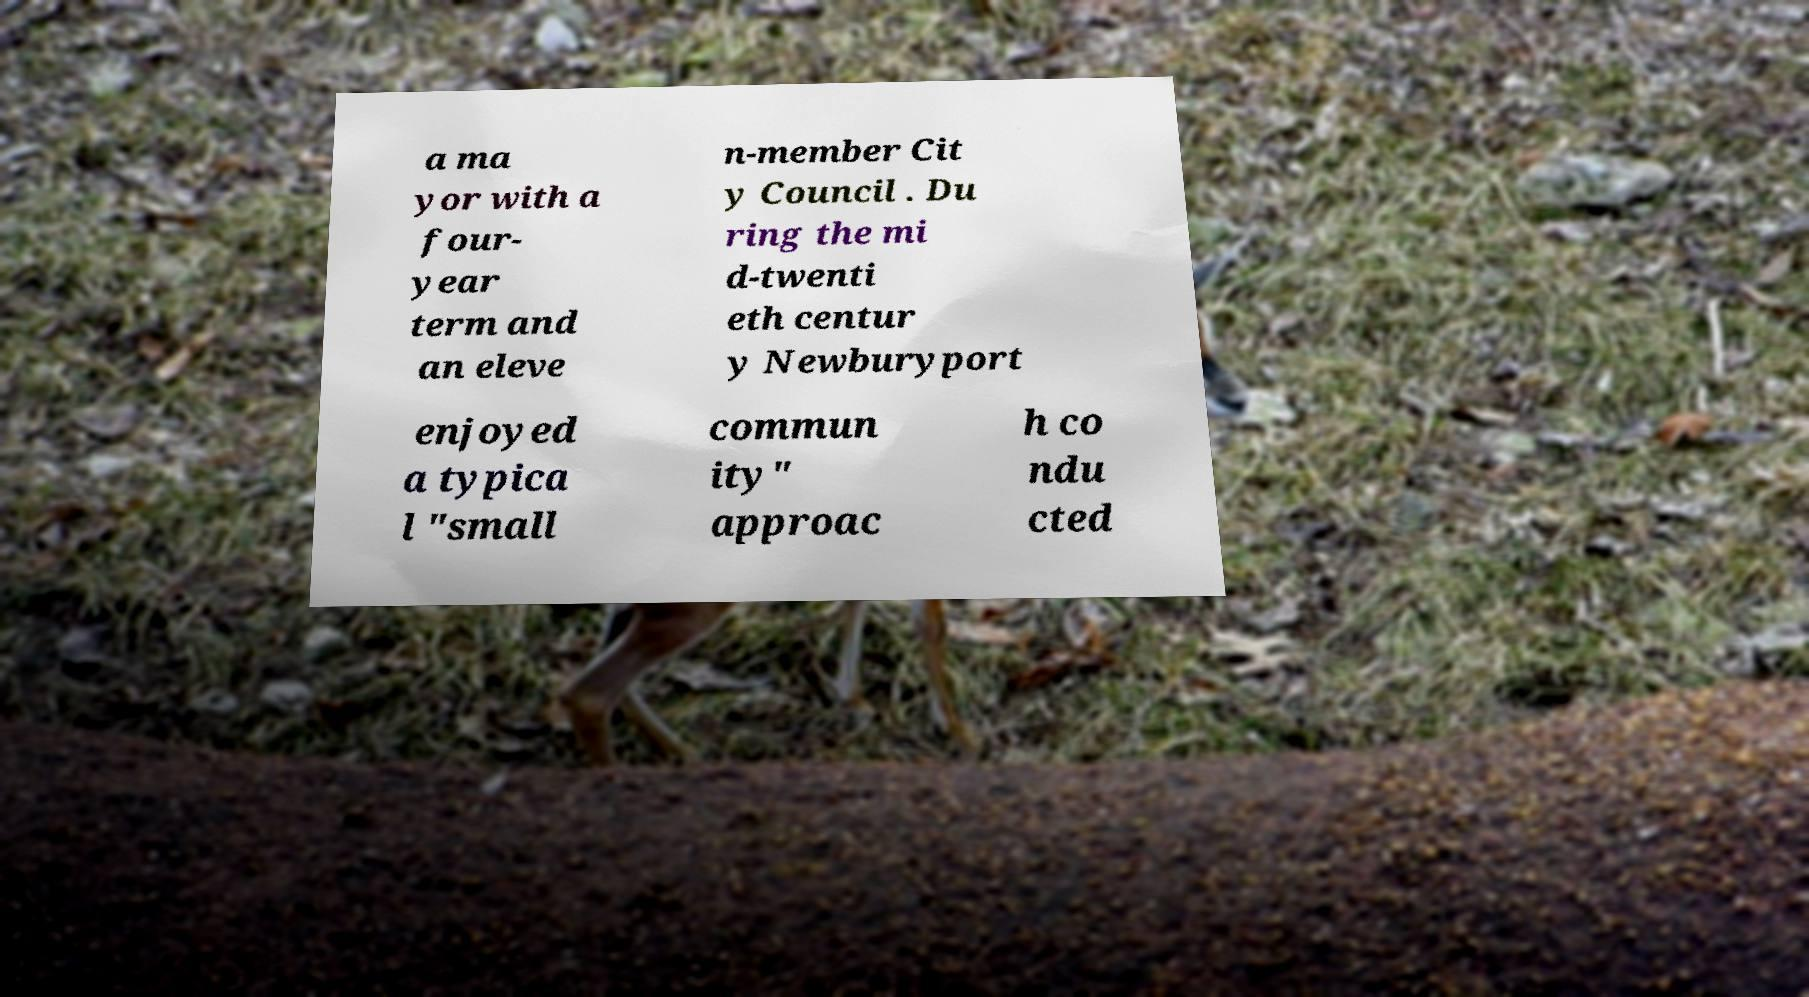Can you accurately transcribe the text from the provided image for me? a ma yor with a four- year term and an eleve n-member Cit y Council . Du ring the mi d-twenti eth centur y Newburyport enjoyed a typica l "small commun ity" approac h co ndu cted 